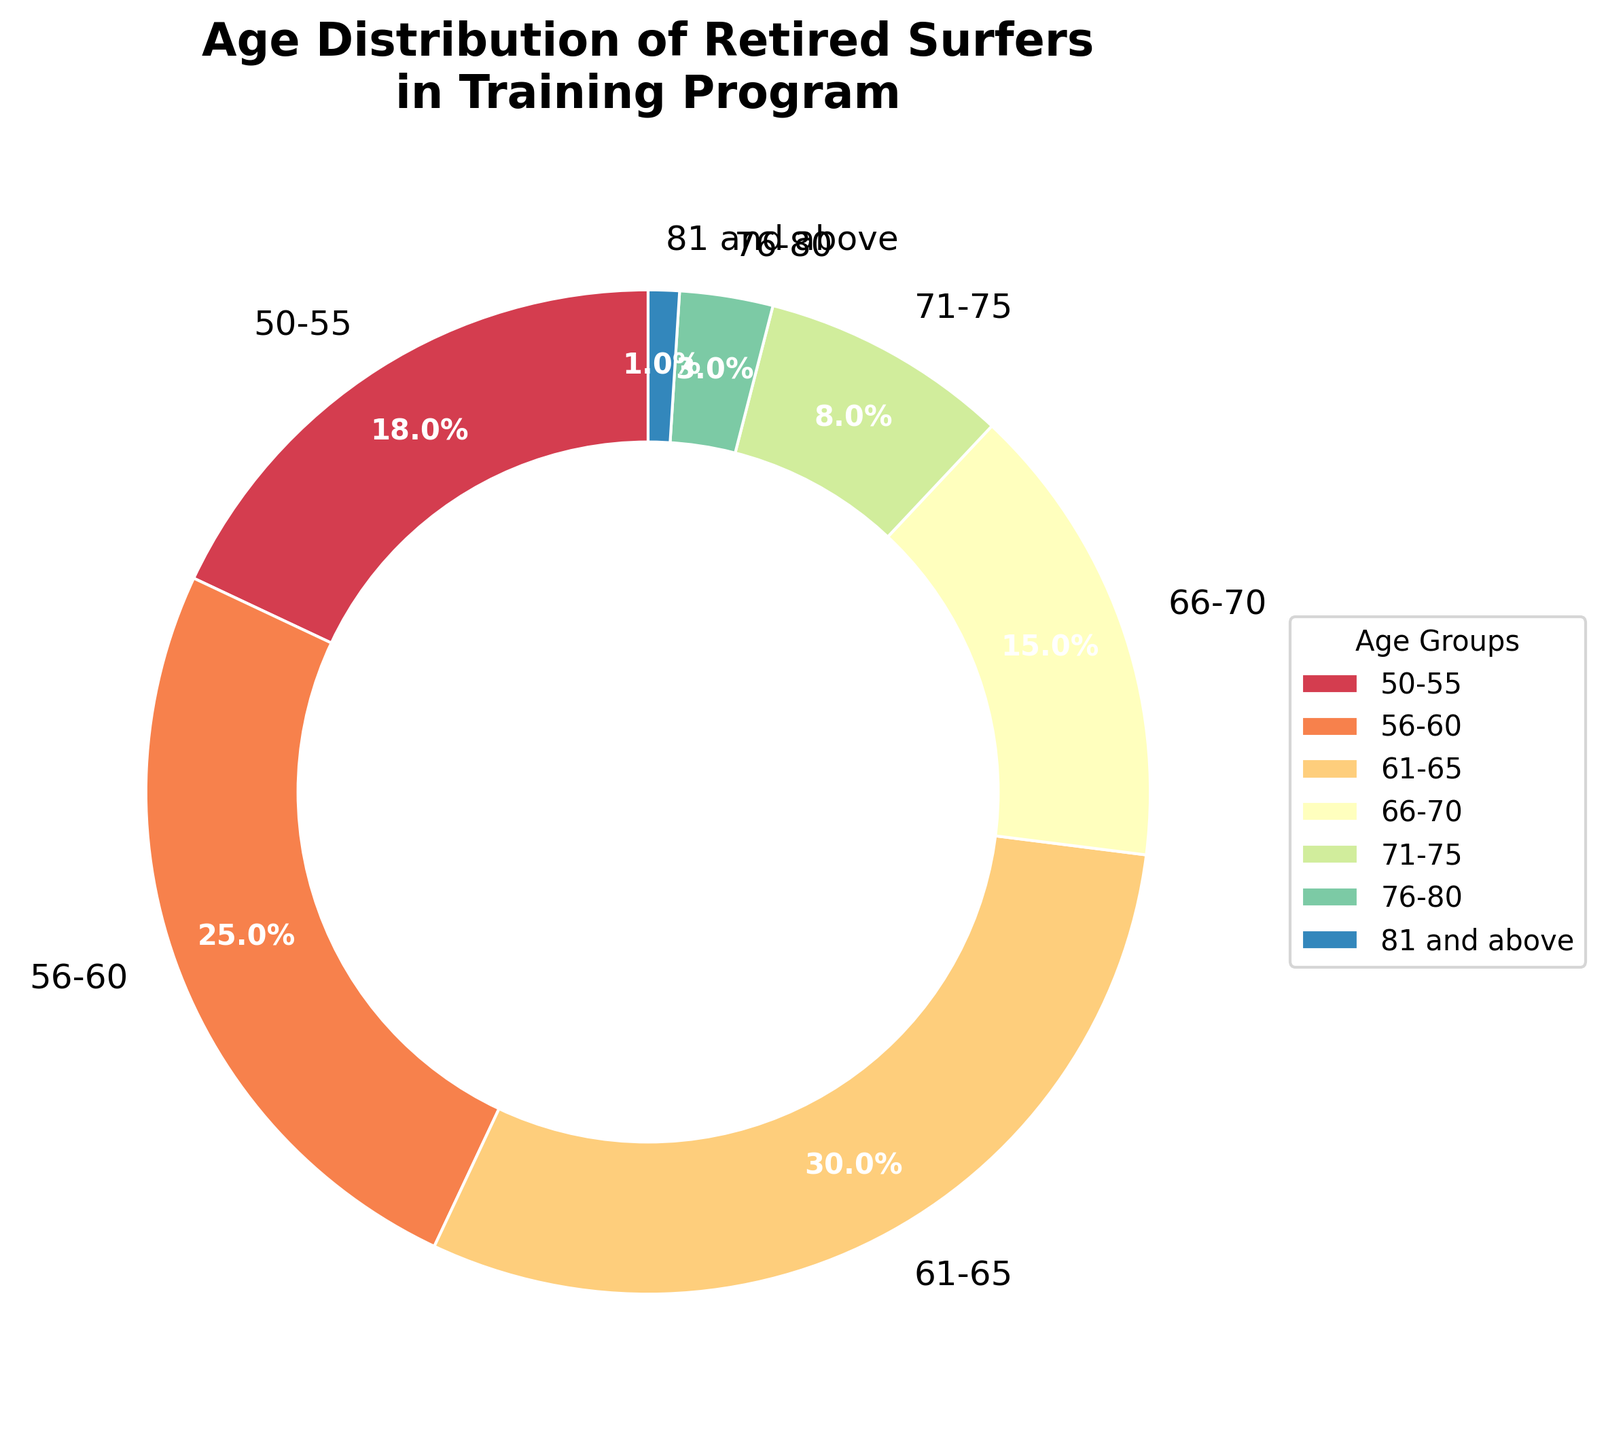Which age group has the highest percentage of surfers participating in the program? The age group 61-65 has the highest percentage at 30%, which can be observed from the labels on the pie chart.
Answer: 61-65 Which two age groups together make up more than half of the participants? The age groups 56-60 (25%) and 61-65 (30%) together contribute 55%, which is more than half (50%) of the total.
Answer: 56-60 and 61-65 What is the percentage difference between the age groups 50-55 and 76-80? The percentage for 50-55 is 18%, and for 76-80 is 3%. The difference is calculated as 18% - 3% = 15%.
Answer: 15% What is the sum of the percentages of participants aged 66-70 and 71-75? The percentage for 66-70 is 15%, and for 71-75 is 8%. The sum is 15% + 8% = 23%.
Answer: 23% Which age group has the smallest representation among the retired surfers in the program? The age group 81 and above has the smallest representation at 1%, according to the pie chart.
Answer: 81 and above How many age groups have a percentage above 20%? There are two age groups above 20%: 56-60 (25%) and 61-65 (30%).
Answer: 2 What is the combined percentage of the age groups 71-75 and 81 and above? The percentage for 71-75 is 8%, and for 81 and above is 1%. The combined percentage is 8% + 1% = 9%.
Answer: 9% Which age group is represented by the second largest slice in the pie chart? The age group 56-60 is the second largest slice at 25%, as observed from the chart.
Answer: 56-60 